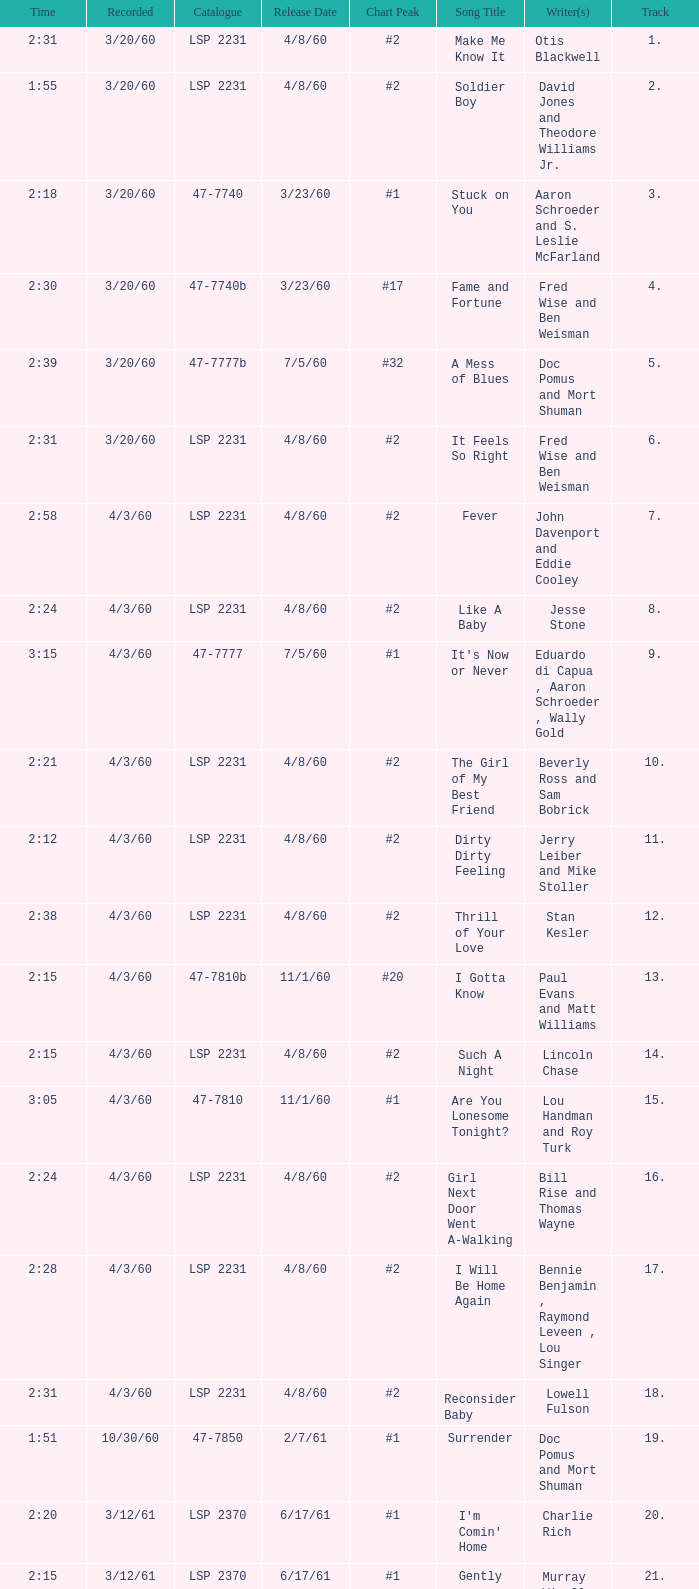What is the time of songs that have the writer Aaron Schroeder and Wally Gold? 1:50. 